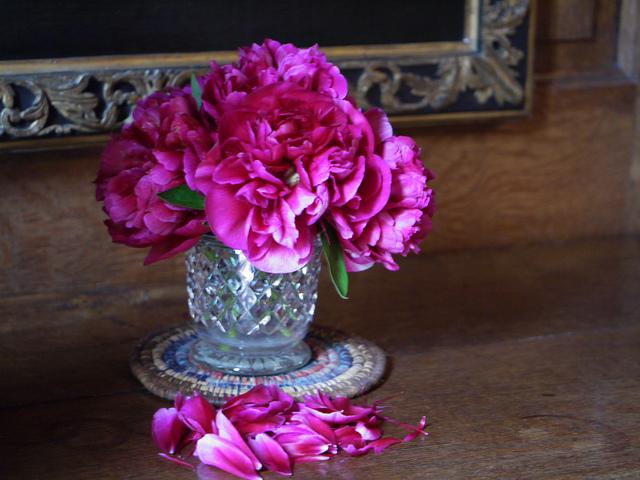What kind of flowers are these?
Short answer required. Roses. What is the vase made of?
Short answer required. Glass. How many flower petals are on the table?
Keep it brief. 15. 